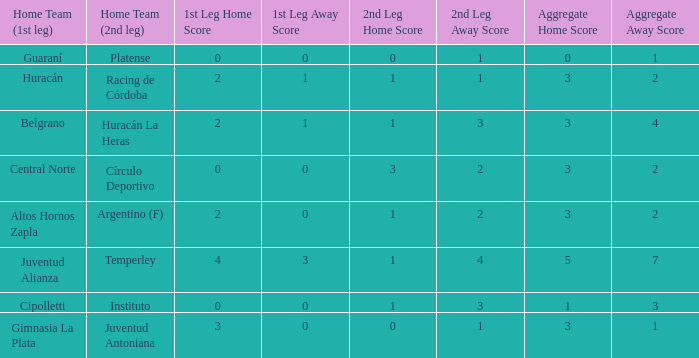Who played at home for the second leg with a score of 0-1 and tied 0-0 in the first leg? Platense. Could you parse the entire table as a dict? {'header': ['Home Team (1st leg)', 'Home Team (2nd leg)', '1st Leg Home Score', '1st Leg Away Score', '2nd Leg Home Score', '2nd Leg Away Score', 'Aggregate Home Score', 'Aggregate Away Score'], 'rows': [['Guaraní', 'Platense', '0', '0', '0', '1', '0', '1'], ['Huracán', 'Racing de Córdoba', '2', '1', '1', '1', '3', '2'], ['Belgrano', 'Huracán La Heras', '2', '1', '1', '3', '3', '4'], ['Central Norte', 'Círculo Deportivo', '0', '0', '3', '2', '3', '2'], ['Altos Hornos Zapla', 'Argentino (F)', '2', '0', '1', '2', '3', '2'], ['Juventud Alianza', 'Temperley', '4', '3', '1', '4', '5', '7'], ['Cipolletti', 'Instituto', '0', '0', '1', '3', '1', '3'], ['Gimnasia La Plata', 'Juventud Antoniana', '3', '0', '0', '1', '3', '1']]} 